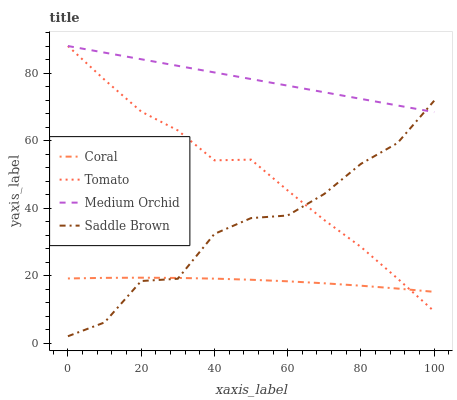Does Coral have the minimum area under the curve?
Answer yes or no. Yes. Does Medium Orchid have the maximum area under the curve?
Answer yes or no. Yes. Does Medium Orchid have the minimum area under the curve?
Answer yes or no. No. Does Coral have the maximum area under the curve?
Answer yes or no. No. Is Medium Orchid the smoothest?
Answer yes or no. Yes. Is Saddle Brown the roughest?
Answer yes or no. Yes. Is Coral the smoothest?
Answer yes or no. No. Is Coral the roughest?
Answer yes or no. No. Does Saddle Brown have the lowest value?
Answer yes or no. Yes. Does Coral have the lowest value?
Answer yes or no. No. Does Medium Orchid have the highest value?
Answer yes or no. Yes. Does Coral have the highest value?
Answer yes or no. No. Is Coral less than Medium Orchid?
Answer yes or no. Yes. Is Medium Orchid greater than Coral?
Answer yes or no. Yes. Does Tomato intersect Medium Orchid?
Answer yes or no. Yes. Is Tomato less than Medium Orchid?
Answer yes or no. No. Is Tomato greater than Medium Orchid?
Answer yes or no. No. Does Coral intersect Medium Orchid?
Answer yes or no. No. 